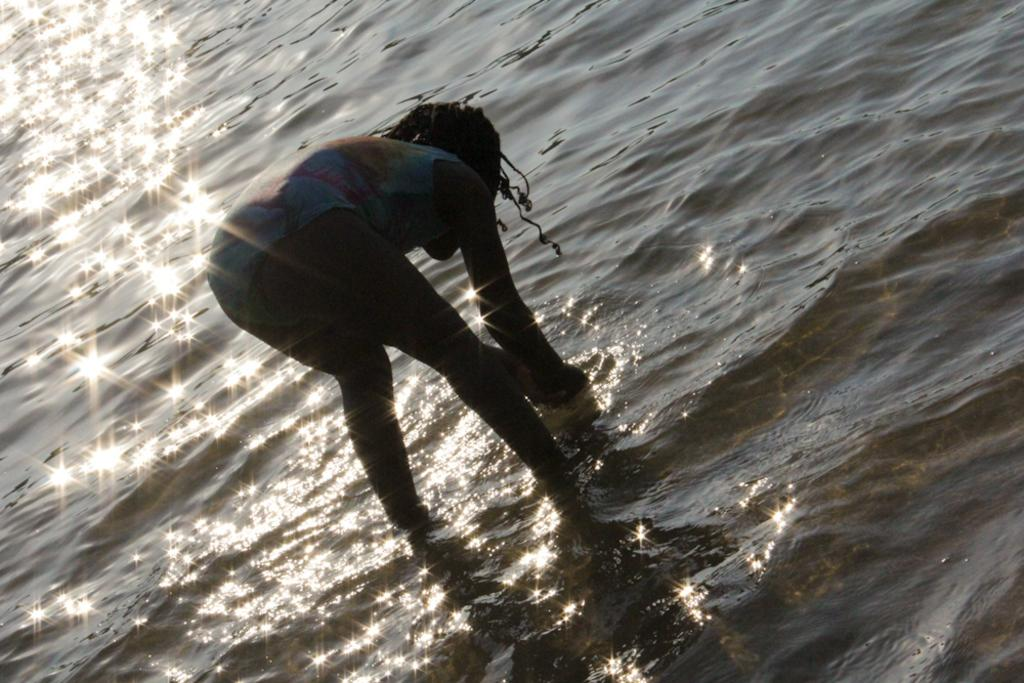Where was the image taken? The image was clicked outside. What is the person in the image doing? The person is standing and bending forward in the center of the image. What can be seen in the background of the image? There is a water body visible in the image. What else can be seen in the image besides the person and the water body? There are other objects present in the image. What type of tail can be seen on the person in the image? There is no tail visible on the person in the image. What season is it in the image, considering the presence of a spring? There is no mention of a spring in the image; it is not possible to determine the season based on the provided facts. 